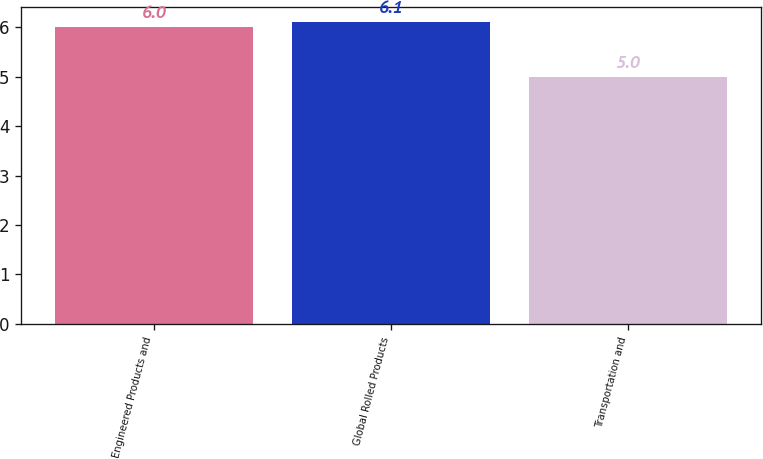Convert chart. <chart><loc_0><loc_0><loc_500><loc_500><bar_chart><fcel>Engineered Products and<fcel>Global Rolled Products<fcel>Transportation and<nl><fcel>6<fcel>6.1<fcel>5<nl></chart> 